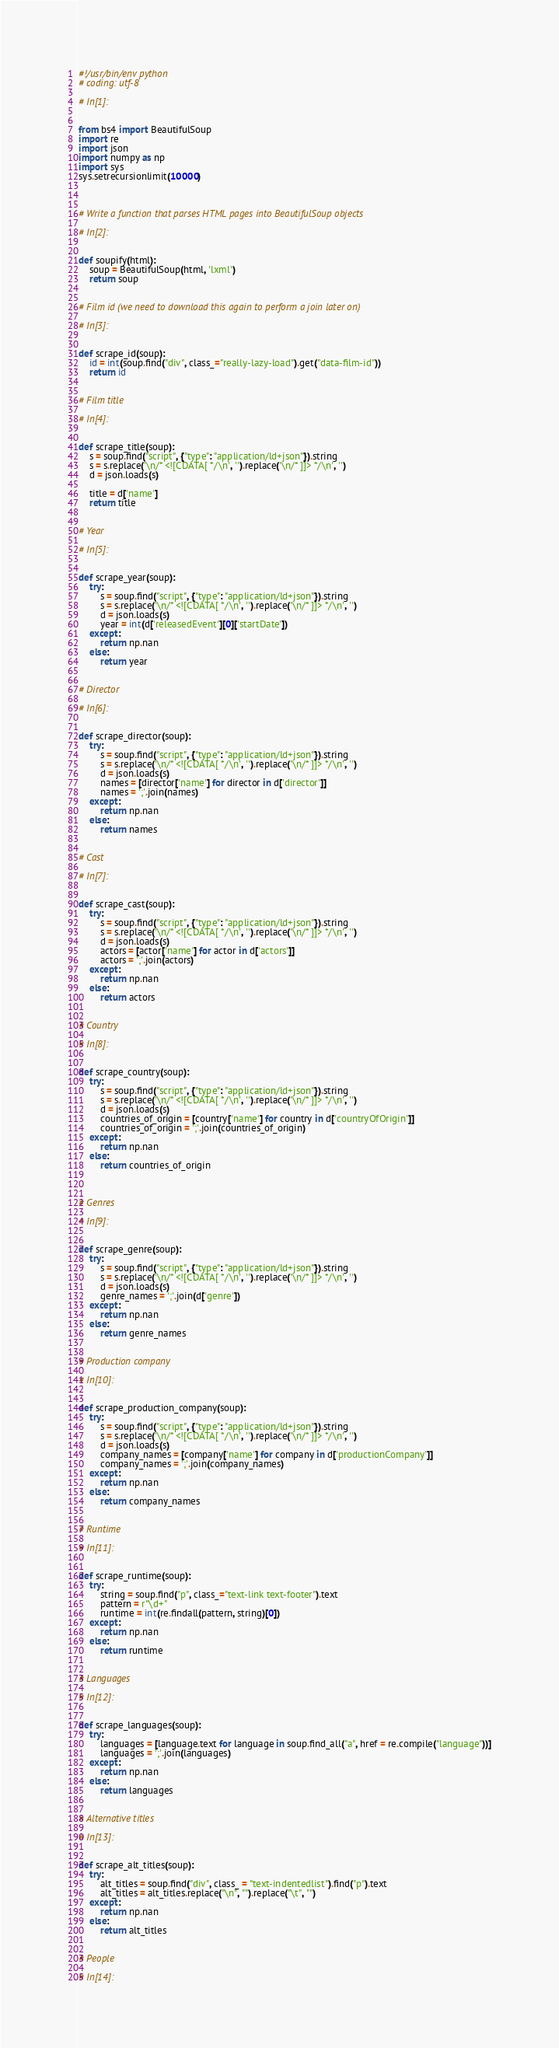<code> <loc_0><loc_0><loc_500><loc_500><_Python_>#!/usr/bin/env python
# coding: utf-8

# In[1]:


from bs4 import BeautifulSoup
import re
import json
import numpy as np
import sys
sys.setrecursionlimit(10000)



# Write a function that parses HTML pages into BeautifulSoup objects

# In[2]:


def soupify(html):
    soup = BeautifulSoup(html, 'lxml')
    return soup


# Film id (we need to download this again to perform a join later on)

# In[3]:


def scrape_id(soup):
    id = int(soup.find("div", class_="really-lazy-load").get("data-film-id"))
    return id


# Film title

# In[4]:


def scrape_title(soup):
    s = soup.find("script", {"type": "application/ld+json"}).string
    s = s.replace('\n/* <![CDATA[ */\n', '').replace('\n/* ]]> */\n', '')
    d = json.loads(s)
    
    title = d['name']
    return title


# Year

# In[5]:


def scrape_year(soup):
    try:
        s = soup.find("script", {"type": "application/ld+json"}).string
        s = s.replace('\n/* <![CDATA[ */\n', '').replace('\n/* ]]> */\n', '')
        d = json.loads(s)
        year = int(d['releasedEvent'][0]['startDate'])
    except:
        return np.nan
    else:
        return year


# Director

# In[6]:


def scrape_director(soup):
    try:
        s = soup.find("script", {"type": "application/ld+json"}).string
        s = s.replace('\n/* <![CDATA[ */\n', '').replace('\n/* ]]> */\n', '')
        d = json.loads(s)
        names = [director['name'] for director in d['director']]
        names = ';'.join(names)
    except:
        return np.nan
    else:
        return names


# Cast

# In[7]:


def scrape_cast(soup):
    try:
        s = soup.find("script", {"type": "application/ld+json"}).string
        s = s.replace('\n/* <![CDATA[ */\n', '').replace('\n/* ]]> */\n', '')
        d = json.loads(s)
        actors = [actor['name'] for actor in d['actors']]
        actors = ';'.join(actors)
    except:
        return np.nan
    else:
        return actors


# Country

# In[8]:


def scrape_country(soup):
    try:
        s = soup.find("script", {"type": "application/ld+json"}).string
        s = s.replace('\n/* <![CDATA[ */\n', '').replace('\n/* ]]> */\n', '')
        d = json.loads(s)
        countries_of_origin = [country['name'] for country in d['countryOfOrigin']]
        countries_of_origin = ';'.join(countries_of_origin)
    except:
        return np.nan
    else:
        return countries_of_origin
   


# Genres

# In[9]:


def scrape_genre(soup):
    try:
        s = soup.find("script", {"type": "application/ld+json"}).string
        s = s.replace('\n/* <![CDATA[ */\n', '').replace('\n/* ]]> */\n', '')
        d = json.loads(s)
        genre_names = ';'.join(d['genre'])
    except:
        return np.nan
    else:
        return genre_names


# Production company

# In[10]:


def scrape_production_company(soup):
    try:
        s = soup.find("script", {"type": "application/ld+json"}).string
        s = s.replace('\n/* <![CDATA[ */\n', '').replace('\n/* ]]> */\n', '')
        d = json.loads(s)
        company_names = [company['name'] for company in d['productionCompany']]
        company_names = ';'.join(company_names)
    except:
        return np.nan
    else:
        return company_names


# Runtime

# In[11]:


def scrape_runtime(soup):
    try:
        string = soup.find("p", class_="text-link text-footer").text
        pattern = r"\d+"
        runtime = int(re.findall(pattern, string)[0])
    except:
        return np.nan
    else:
        return runtime


# Languages

# In[12]:


def scrape_languages(soup):
    try:
        languages = [language.text for language in soup.find_all("a", href = re.compile("language"))]
        languages = ';'.join(languages)
    except:
        return np.nan
    else:
        return languages


# Alternative titles

# In[13]:


def scrape_alt_titles(soup):
    try:
        alt_titles = soup.find("div", class_ = "text-indentedlist").find("p").text
        alt_titles = alt_titles.replace("\n", "").replace("\t", "")
    except:
        return np.nan
    else:
        return alt_titles


# People

# In[14]:

</code> 